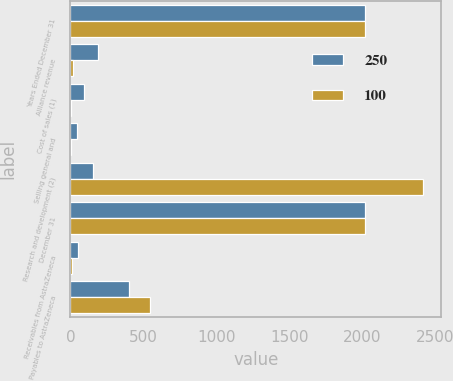Convert chart. <chart><loc_0><loc_0><loc_500><loc_500><stacked_bar_chart><ecel><fcel>Years Ended December 31<fcel>Alliance revenue<fcel>Cost of sales (1)<fcel>Selling general and<fcel>Research and development (2)<fcel>December 31<fcel>Receivables from AstraZeneca<fcel>Payables to AstraZeneca<nl><fcel>250<fcel>2018<fcel>187<fcel>93<fcel>48<fcel>152<fcel>2018<fcel>52<fcel>405<nl><fcel>100<fcel>2017<fcel>20<fcel>4<fcel>1<fcel>2419<fcel>2017<fcel>12<fcel>543<nl></chart> 